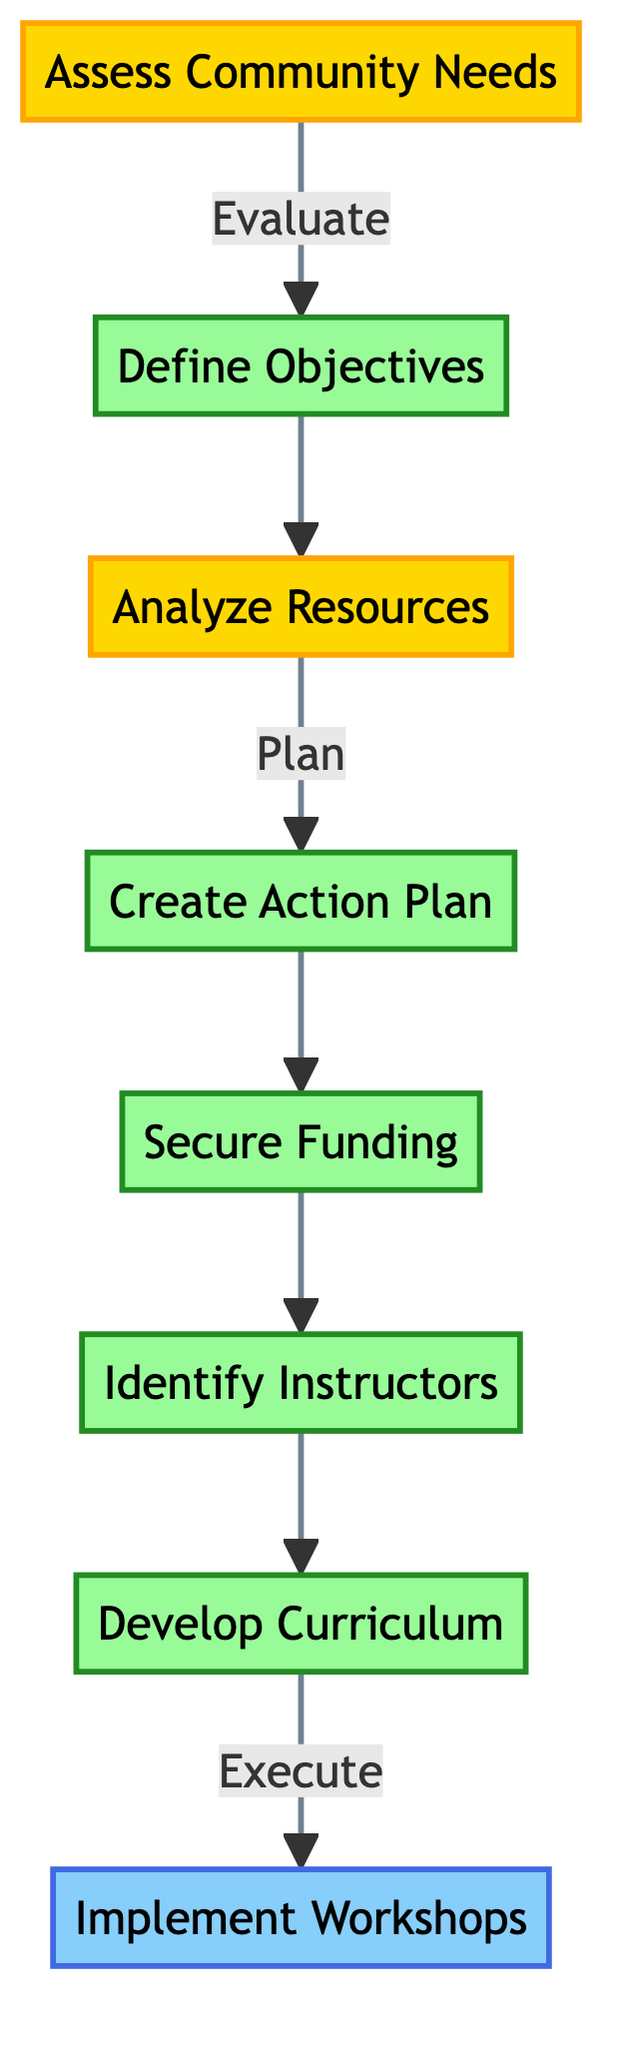What is the first step in the flowchart? The first step in the flowchart is "Assess Community Needs," which is positioned at the bottom of the flowchart, indicating the starting point of the process.
Answer: Assess Community Needs How many planning steps are there in this flowchart? The planning steps in the flowchart include "Develop Curriculum," "Identify Instructors," "Secure Funding," and "Create Action Plan," totaling four steps.
Answer: Four What is the last step before implementing the workshops? The last step before implementing the workshops is "Develop Curriculum," which flows directly into the "Implement Workshops" node.
Answer: Develop Curriculum What type is "Define Objectives"? "Define Objectives" is classified as a planning step, as indicated by its color and position in the flowchart.
Answer: Planning What two steps precede "Analyze Resources"? The two steps that precede "Analyze Resources" in the flowchart are "Define Objectives" and "Create Action Plan," which are directly connected before it.
Answer: Define Objectives, Create Action Plan Which node has an execution type? The node that has an execution type is "Implement Workshops," which is where the execution of the program takes place according to the flowchart.
Answer: Implement Workshops What is the relationship between "Secure Funding" and "Identify Instructors"? The relationship is that "Secure Funding" directly precedes "Identify Instructors," indicating that securing funding must happen before identifying instructors.
Answer: Sequential Which node comes after "Assess Community Needs"? "Define Objectives" comes immediately after "Assess Community Needs," as shown in the flowchart's upward progression.
Answer: Define Objectives How many evaluation steps are included in this flowchart? There are two evaluation steps in the flowchart: "Assess Community Needs" and "Analyze Resources," which are marked as evaluation nodes.
Answer: Two 